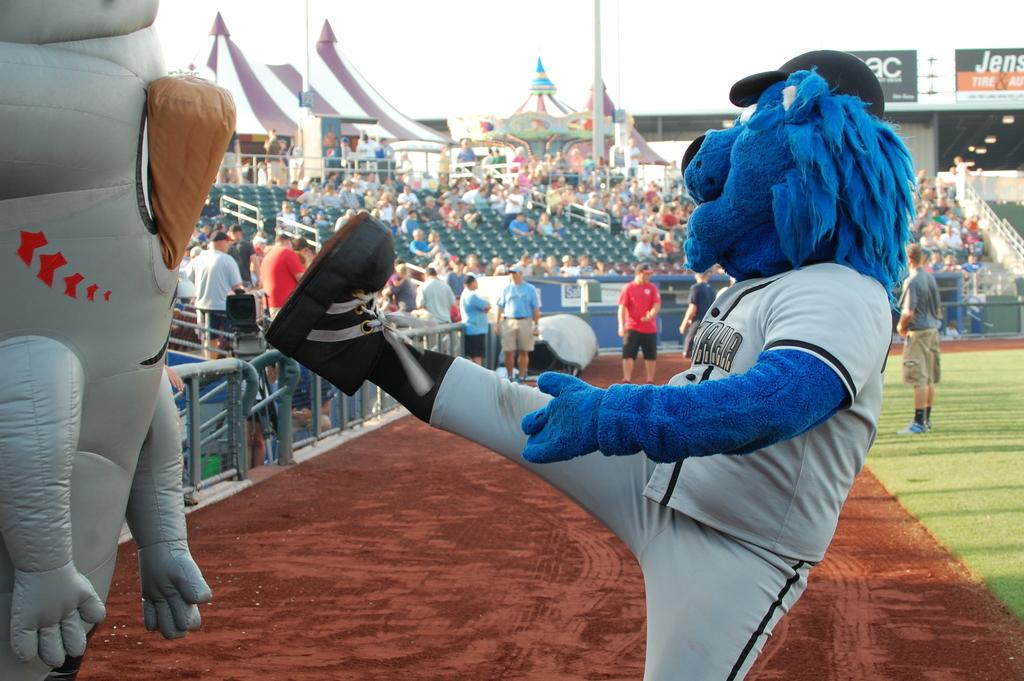<image>
Summarize the visual content of the image. The letters a and c can be seen on a sign at a baseball diamond. 